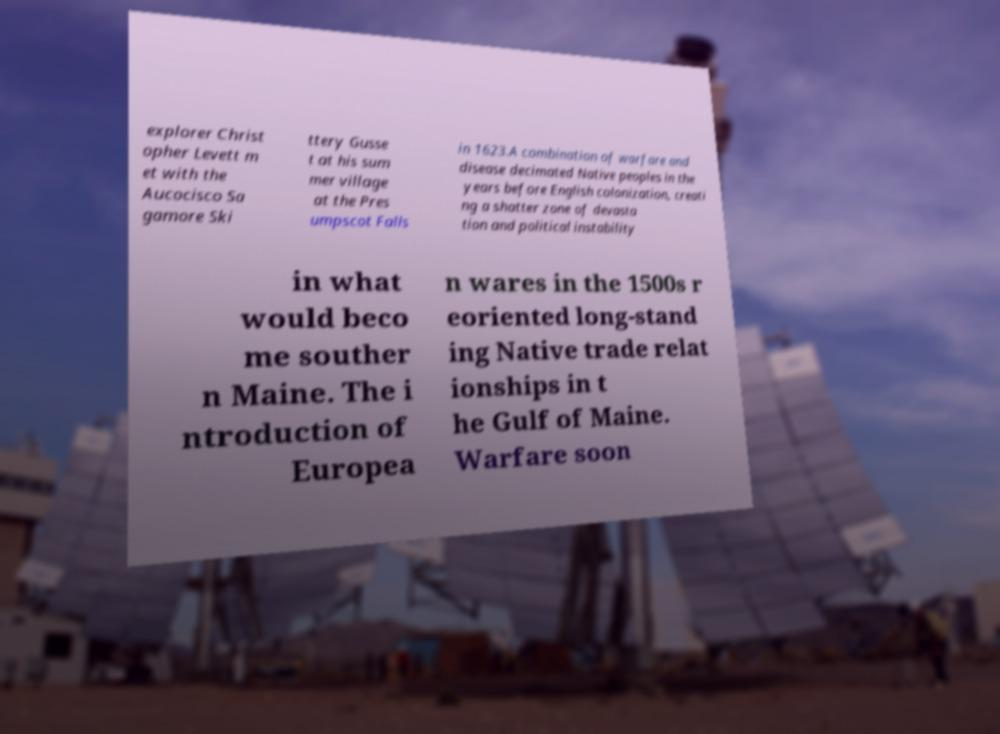Please identify and transcribe the text found in this image. explorer Christ opher Levett m et with the Aucocisco Sa gamore Ski ttery Gusse t at his sum mer village at the Pres umpscot Falls in 1623.A combination of warfare and disease decimated Native peoples in the years before English colonization, creati ng a shatter zone of devasta tion and political instability in what would beco me souther n Maine. The i ntroduction of Europea n wares in the 1500s r eoriented long-stand ing Native trade relat ionships in t he Gulf of Maine. Warfare soon 